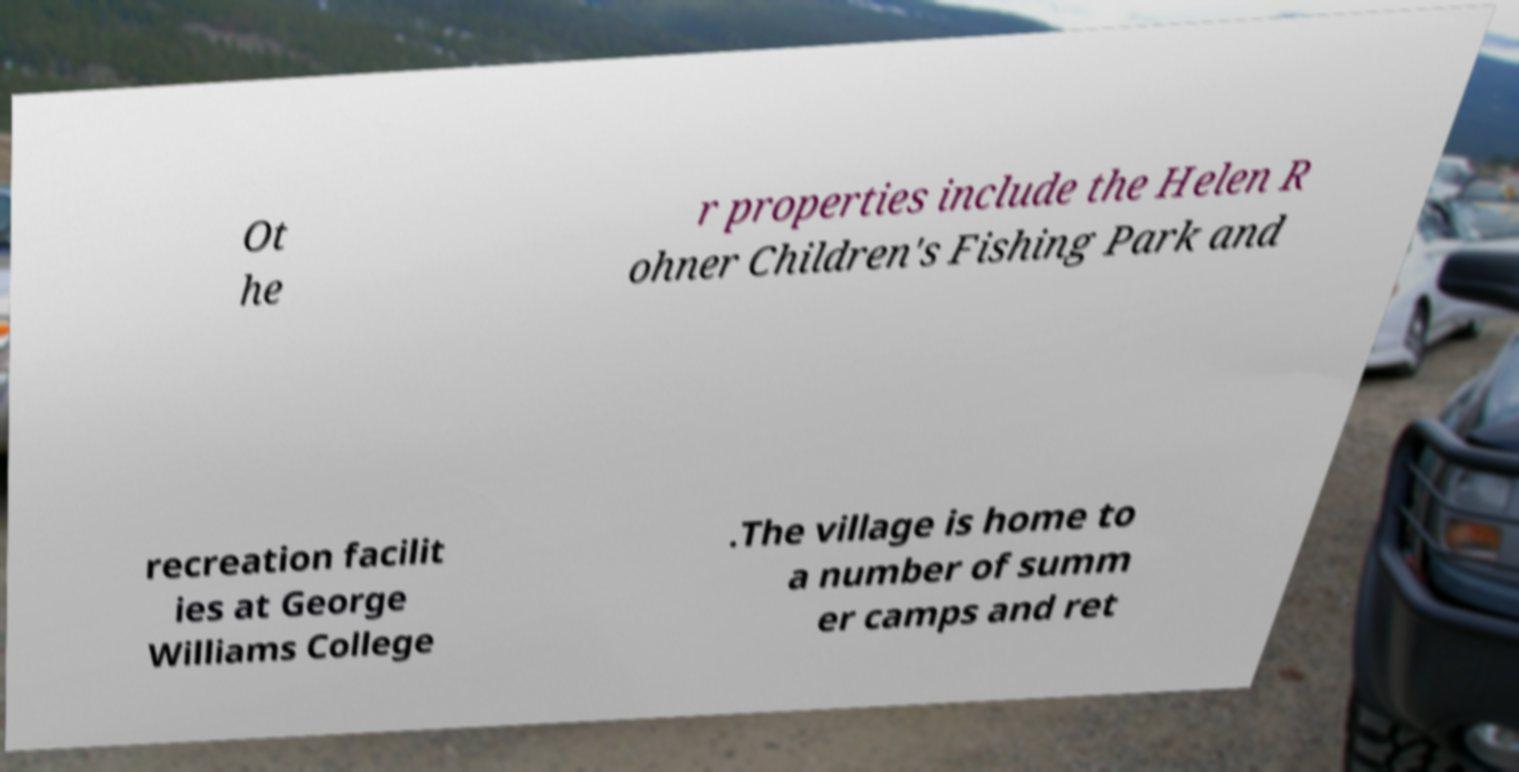Could you assist in decoding the text presented in this image and type it out clearly? Ot he r properties include the Helen R ohner Children's Fishing Park and recreation facilit ies at George Williams College .The village is home to a number of summ er camps and ret 